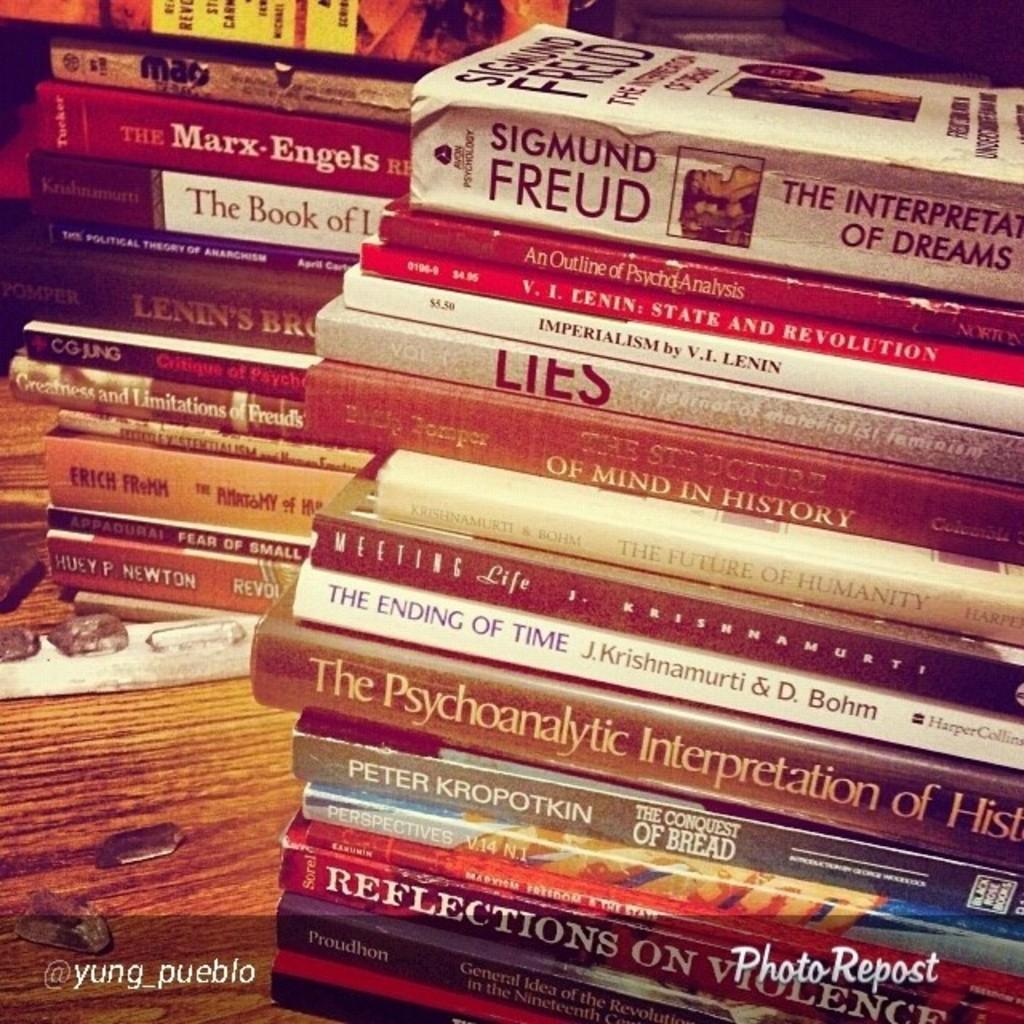Is the ending of time book here?
Give a very brief answer. Yes. 